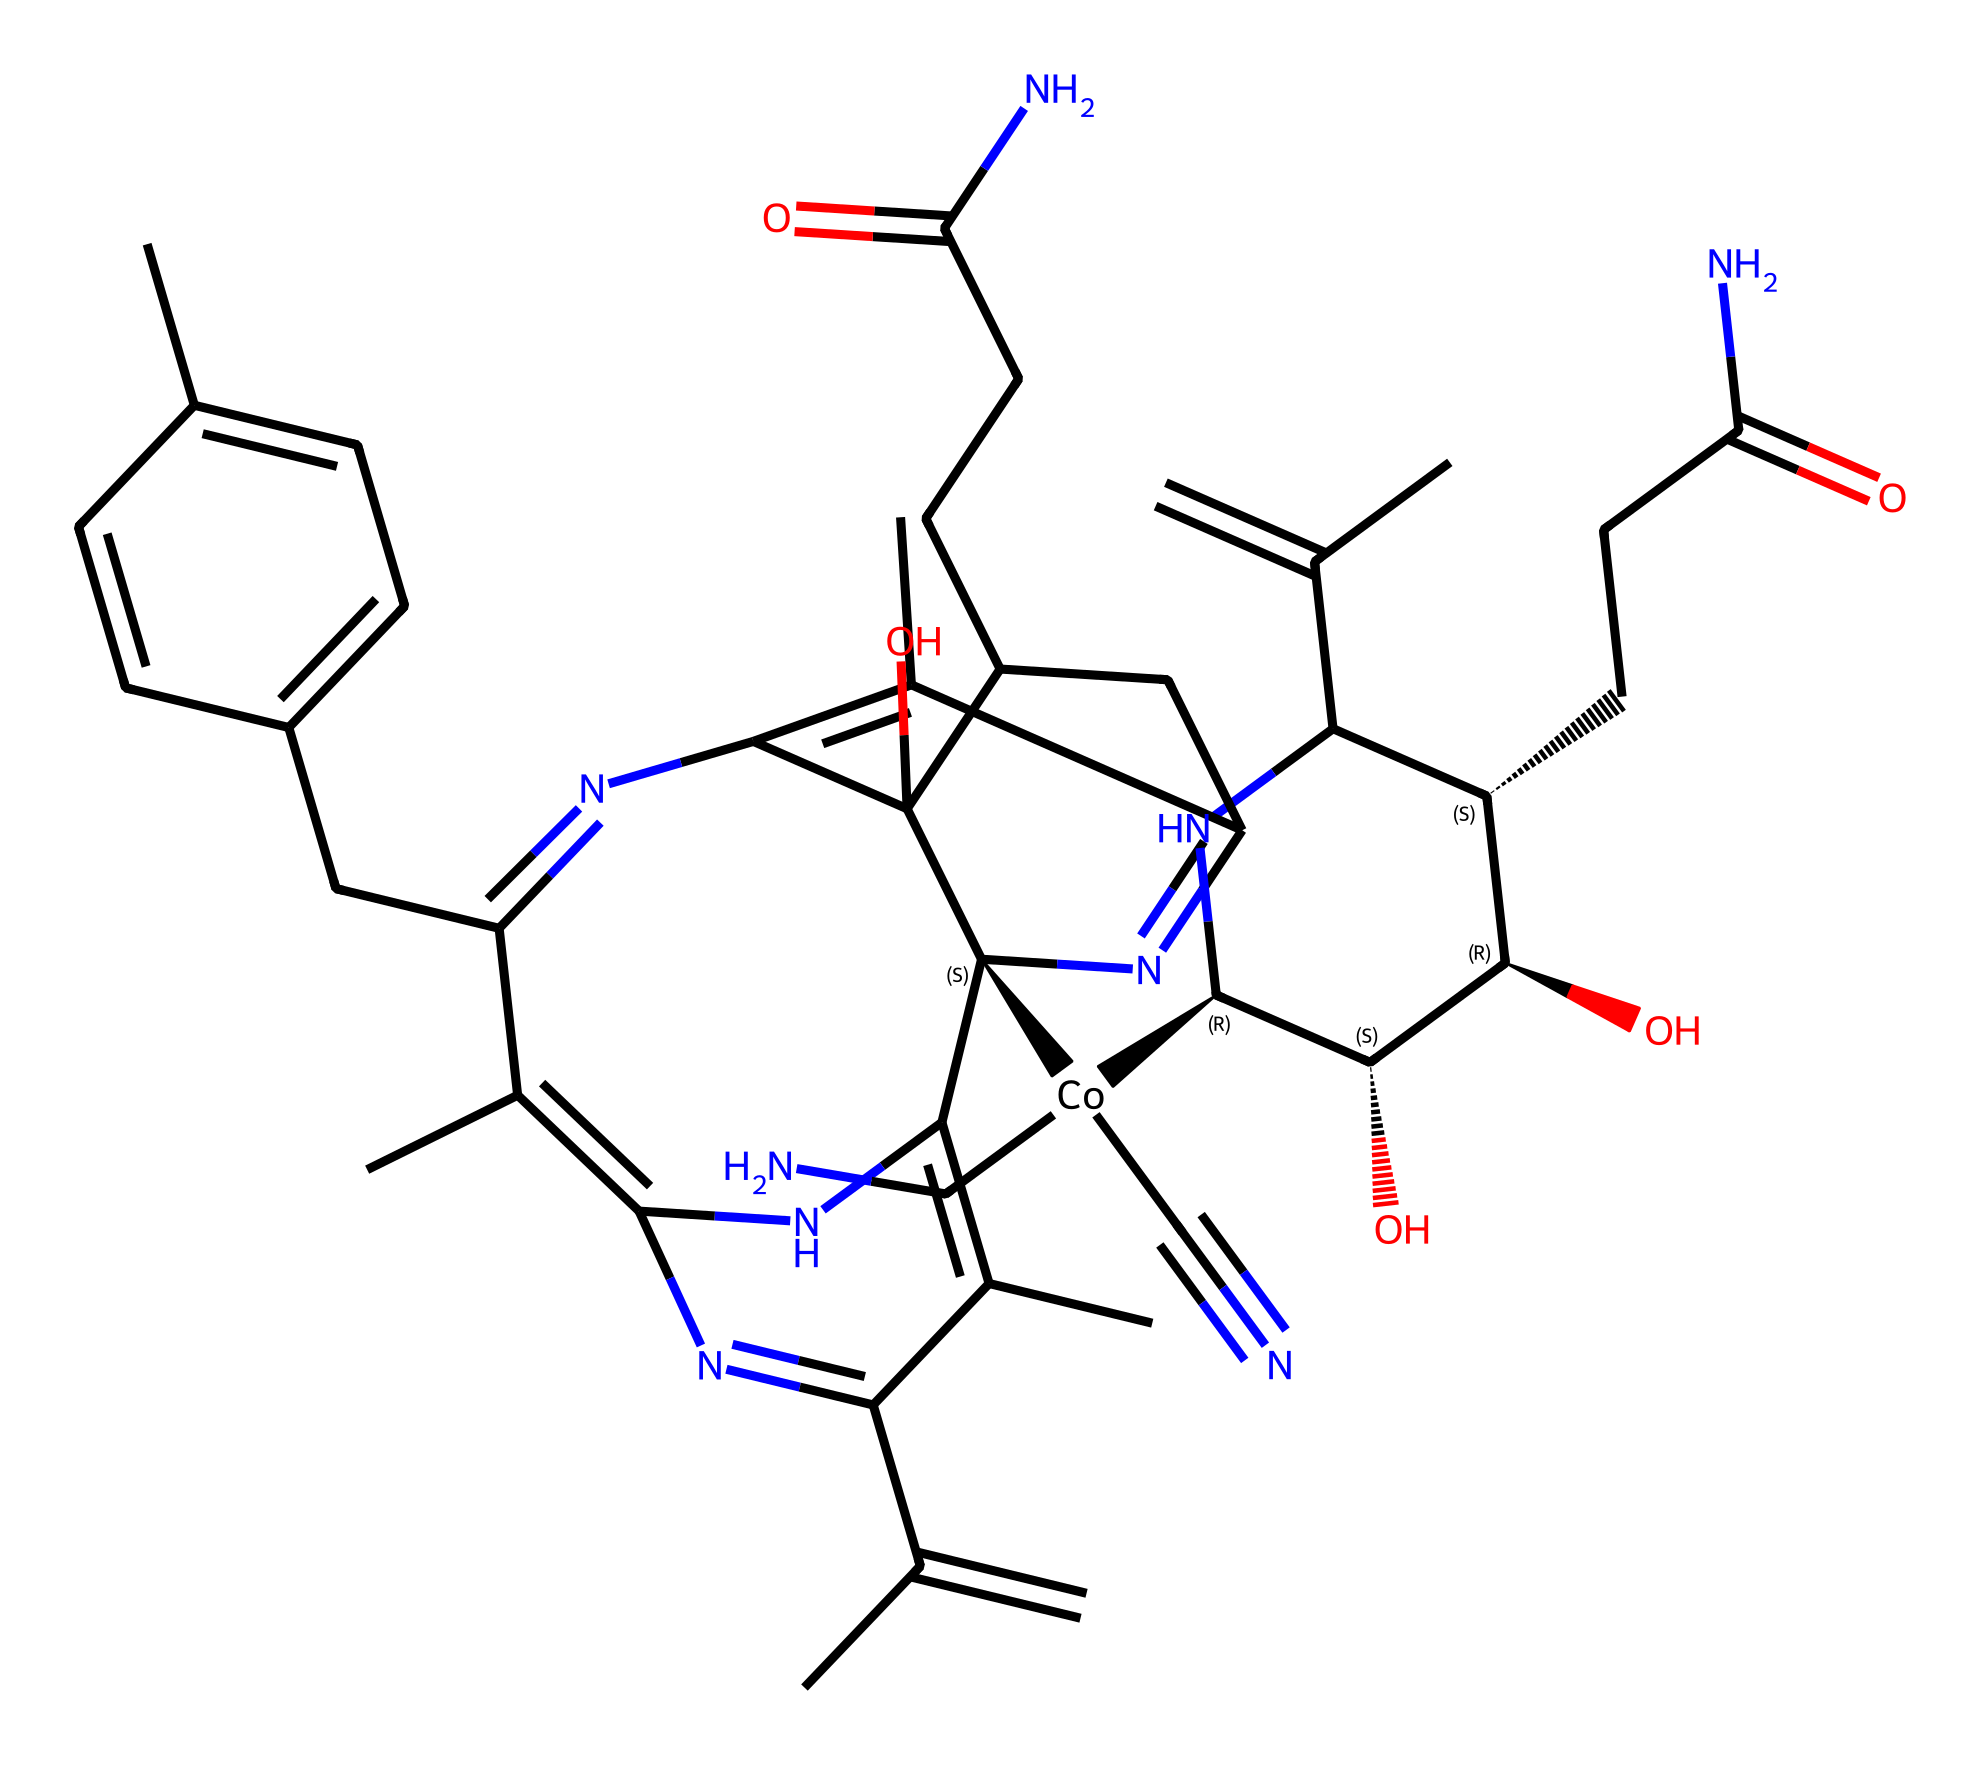What is the central metal atom in vitamin B12? This chemical structure contains a cobalt atom, which is at the core of the structure, signifying its role as the central metal in vitamin B12.
Answer: cobalt How many nitrogen atoms are present in this structure? By analyzing the structure, we can count the number of nitrogen atoms visible, which is a total of 5 within the rings and side chains.
Answer: 5 What type of molecule is represented by this SMILES notation? The structure corresponds to a vitamin, specifically vitamin B12, which is classified as a complex molecule due to its intricate arrangement and numerous functional groups.
Answer: vitamin What functional groups can be identified in this compound? The structure contains amine groups (from the -NH2 parts), hydroxyl groups (-OH), and carboxyl groups (-COOH), indicating various functionalities in the molecule.
Answer: amine, hydroxyl, carboxyl How many rings are present in the vitamin B12 structure? Upon examining the chemical structure, there are four distinct ring systems prevalent in vitamin B12, essential for its biological function.
Answer: 4 What is the primary use of vitamin B12 in energy drinks? Vitamin B12 is primarily used in energy drinks for its role in energy metabolism, helping to convert nutrients into energy.
Answer: energy metabolism What distinguishes vitamin B12 from other vitamins regarding its structure? The distinguishing factor of vitamin B12 is its cobalt-containing core (cobalamin), which sets it apart from other vitamins that do not contain metals.
Answer: cobalt core 